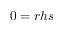Convert formula to latex. <formula><loc_0><loc_0><loc_500><loc_500>0 = r h s</formula> 